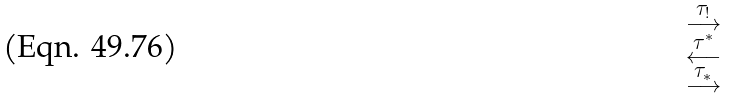<formula> <loc_0><loc_0><loc_500><loc_500>\begin{smallmatrix} \tau _ { ! } \\ \longrightarrow \\ \tau ^ { * } \\ \longleftarrow \\ \tau _ { * } \\ \longrightarrow \end{smallmatrix}</formula> 